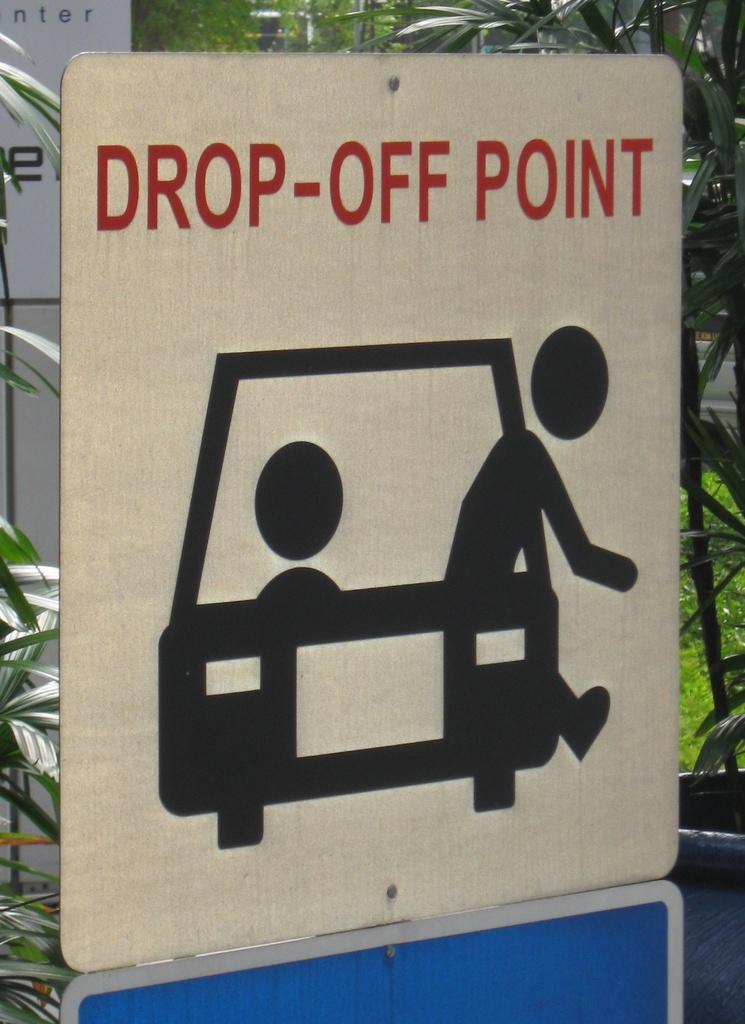<image>
Describe the image concisely. A white sign showing people getting out of a car says Drop-Off Point in red letters. 